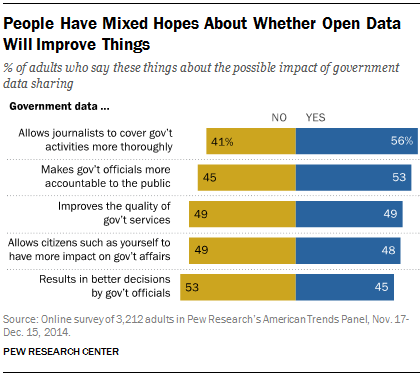Highlight a few significant elements in this photo. The yellow bar represents the value of X. The maximum difference between "yes" and "no" among different opinions is 15. 